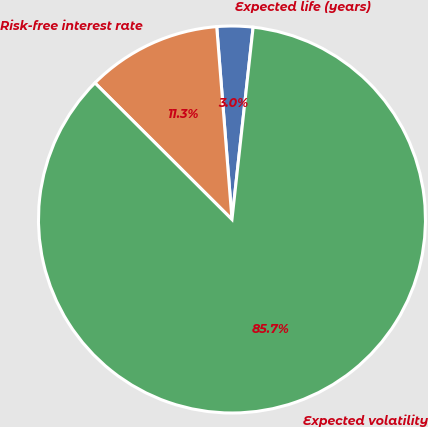<chart> <loc_0><loc_0><loc_500><loc_500><pie_chart><fcel>Expected life (years)<fcel>Risk-free interest rate<fcel>Expected volatility<nl><fcel>3.0%<fcel>11.27%<fcel>85.73%<nl></chart> 